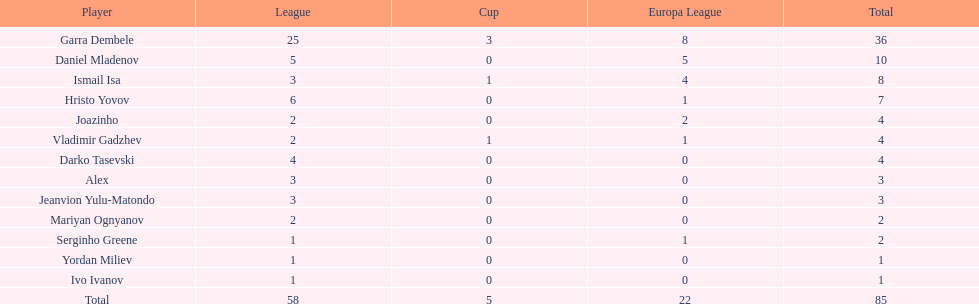Can you provide the count of goals ismail isa has scored during this season? 8. 